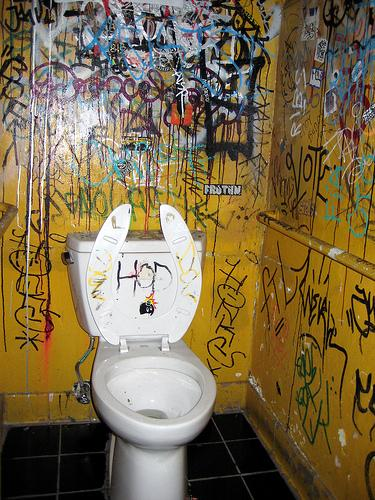Identify the primary object, its condition, and what is written on it. The toilet is dirty and has graffiti that says hod. Describe the color and condition of the walls in the image as well as any additional details. The walls are yellow, dirty, and covered in multicolored graffiti. What is the condition of the toilet and the walls in the image? The toilet is unclean, and the walls are also dirty and besmirched with graffiti. Mention the primary object in the image, its color, and the color of the floor. The primary object is a white toilet, and the floor is black in color. Describe the colors and state of the walls and floor in the image. The walls are dirty and yellow, covered in graffiti, and the floor is black and tiled. Mention the primary object in the picture and describe its state and any additional features. The primary object is a toilet that is white, dirty, and has a silver handle on it. Talk about the key features of the toilet in the image and the state of the walls. The toilet is white, dirty, and adorned with graffiti; the walls are yellow and graffitied. In a few words, describe the color of the floor, walls, and toilet, and what is written on the toilet. Black floor, yellow walls, white toilet, graffiti saying hod. Provide a concise description of the walls, floor, and main object in the image. Graffiti-covered yellow walls, black tiled floor, and a white toilet with graffiti. Briefly describe the appearance of the toilet and the walls surrounding it. The toilet is white and covered in graffiti, while the walls are yellow with graffiti as well. Can you see a wooden floor in the image? No, it's not mentioned in the image. There is a green pipe hanging on the wall. The described image only mentions a silver pipe and a yellow pipe, with no indication of a green pipe. 